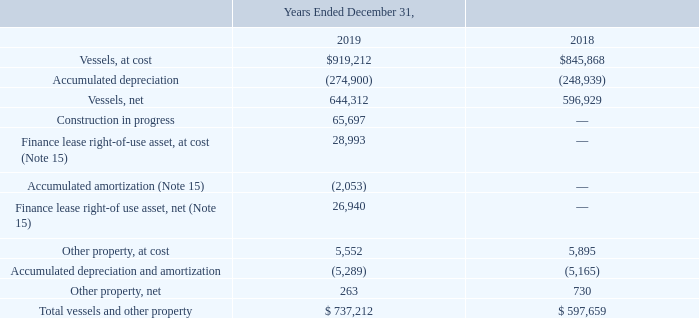NOTE 5 — VESSELS, OTHER PROPERTY AND DEFERRED DRYDOCK
Vessels and other property consist of the following:
On September 30, 2019, the Company took delivery of two 50,000 DWT class product and chemical tankers at Hyundai Mipo Dockyard Co., Ltd. The tankers, named the Overseas Gulf Coast and Overseas Sun Coast, are operating in the international market under the Marshall Islands flag, with both vessels having entered into one-year time charters.
In September 2019, the Company sold one of its ATBs for $1,234, net of broker commissions. As a result of the sale, the Company recognized an immaterial gain, which is included in loss/(gain) on disposal of vessels and other property, including impairments, net on the consolidated statements of operations.
In May and June 2019, the Company sold two of its ATBs for $1,101 and $1,069, respectively, net of broker commissions. As a result of the sales, the Company recognized an immaterial loss, which is included in loss/(gain) on disposal of vessels and other property, including impairments, net on the consolidated statements of operations.
In July 2018 and January 2019, the Company signed binding contracts with Greenbrier Marine (formerly Gunderson Marine LLC) for the construction of two approximately 204,000 BBL, oil and chemical tank barges. The anticipated delivery of the barges to the Company is during the first and second half of 2020, respectively. The Company's remaining commitments under the contracts are $45,849 in 2020.
On December 6, 2018, the Company sold one ATB and one barge for $2,367, net of broker commissions. As a result of the sale, the Company recognized a gain of $877, which is included in loss/(gain) on disposal of vessels and other property, including impairments, net on the consolidated statements of operations.
In June 2018, one of the Company's ATBs was berthed to the dock when a third-party ship transiting the channel hit the Company's ATB causing structural damage to the Company's ATB and damage to the dock. The cost of repairs has been covered by existing insurance policies. The Company has filed a lawsuit against the third-party ship seeking recovery of its costs of repairs as well as its lost earnings from the ATB being off-hire for 46 repair days.
At December 31, 2019, the Company’s owned vessel fleet with a weighted average age of 8.2 years, consisted of six Handysize Product Carriers, two lightering ATBs and two clean ATBs. These vessels are pledged as collateral under the term loan agreements and have an aggregate carrying value of $634,379.
When did the Company sold one ATB and one barge for $2,367? December 6, 2018. What is the change in Total vessels and other property from Years Ended December 31, 2018 to 2019? 737,212-597,659
Answer: 139553. What is the average Total vessels and other property for Years Ended December 31, 2018 to 2019? (737,212+597,659) / 2
Answer: 667435.5. In which year was Vessels, at cost less than 900,000? Locate and analyze vessels, at cost in row 3
answer: 2018. What was the value of Vessels, net in 2019 and 2018 respectively? 644,312, 596,929. When did the company take the delivery of two 50,000 DWT class products? September 30, 2019. 